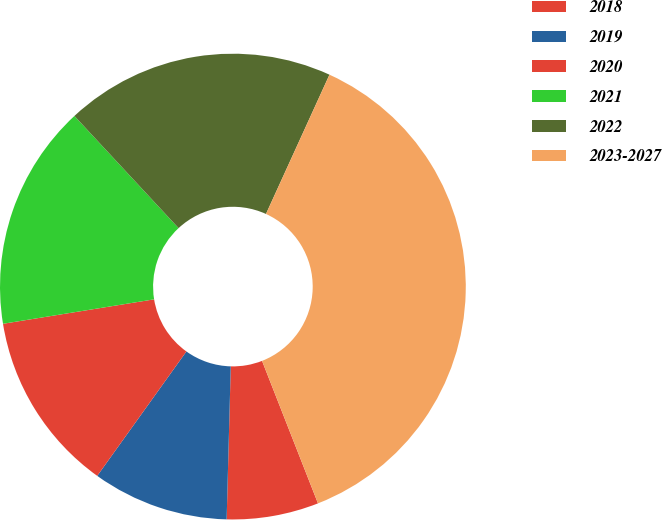Convert chart. <chart><loc_0><loc_0><loc_500><loc_500><pie_chart><fcel>2018<fcel>2019<fcel>2020<fcel>2021<fcel>2022<fcel>2023-2027<nl><fcel>6.38%<fcel>9.47%<fcel>12.55%<fcel>15.64%<fcel>18.72%<fcel>37.24%<nl></chart> 